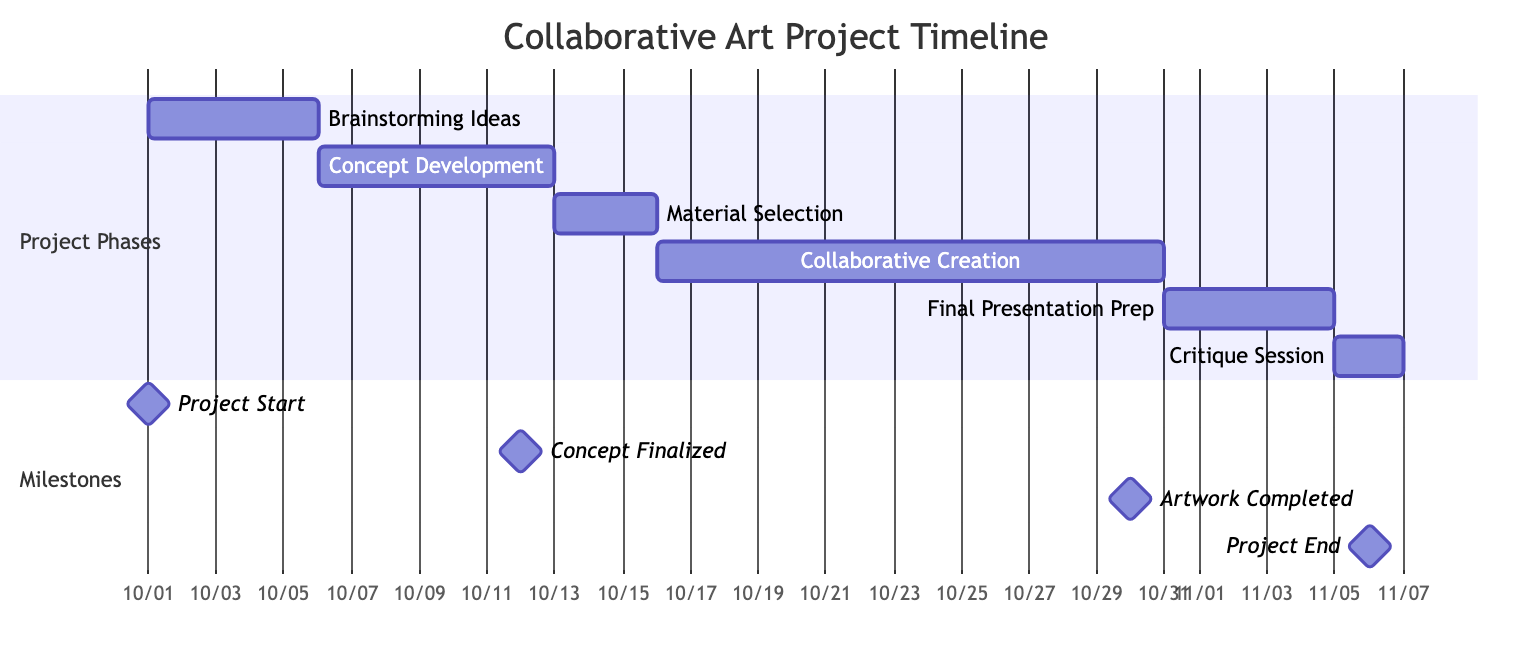What is the duration of the "Collaborative Creation" phase? The "Collaborative Creation" phase starts on October 16, 2023, and ends on October 30, 2023. To find the duration, calculate the number of days between these two dates, which is 15 days.
Answer: 15 days Which phase occurs immediately after "Material Selection"? After "Material Selection," the next phase in the timeline is "Collaborative Creation." This can be determined by looking at the flow of phases as represented in the Gantt chart.
Answer: Collaborative Creation When does the "Final Presentation Preparation" phase begin? The "Final Presentation Preparation" phase starts on October 31, 2023. This is indicated by the starting date assigned to this phase in the Gantt chart.
Answer: October 31, 2023 What is the total number of phases in the project? There are six phases in total: Brainstorming Ideas, Concept Development, Material Selection, Collaborative Creation, Final Presentation Preparation, and Critique Session. Counting each listed phase gives the total.
Answer: 6 What milestone marks the completion of the artwork? The milestone that marks the completion of the artwork is "Artwork Completed." This milestone is specifically identified in the milestones section of the Gantt chart.
Answer: Artwork Completed How many days is the "Critique Session"? The "Critique Session" is scheduled to last for 2 days, as indicated by its start and end dates on the Gantt chart.
Answer: 2 days What phase has the longest duration? The "Collaborative Creation" phase has the longest duration at 15 days, which is longer than any other phase in the project timeline.
Answer: Collaborative Creation Which phase starts on the same date the project starts? The phase "Brainstorming Ideas" starts on the same date the project begins, which is October 1, 2023. This can be found at the beginning of the Gantt chart.
Answer: Brainstorming Ideas What is the end date of the project? The end date of the project is November 6, 2023, which corresponds to the last milestone "Project End" in the Gantt chart.
Answer: November 6, 2023 